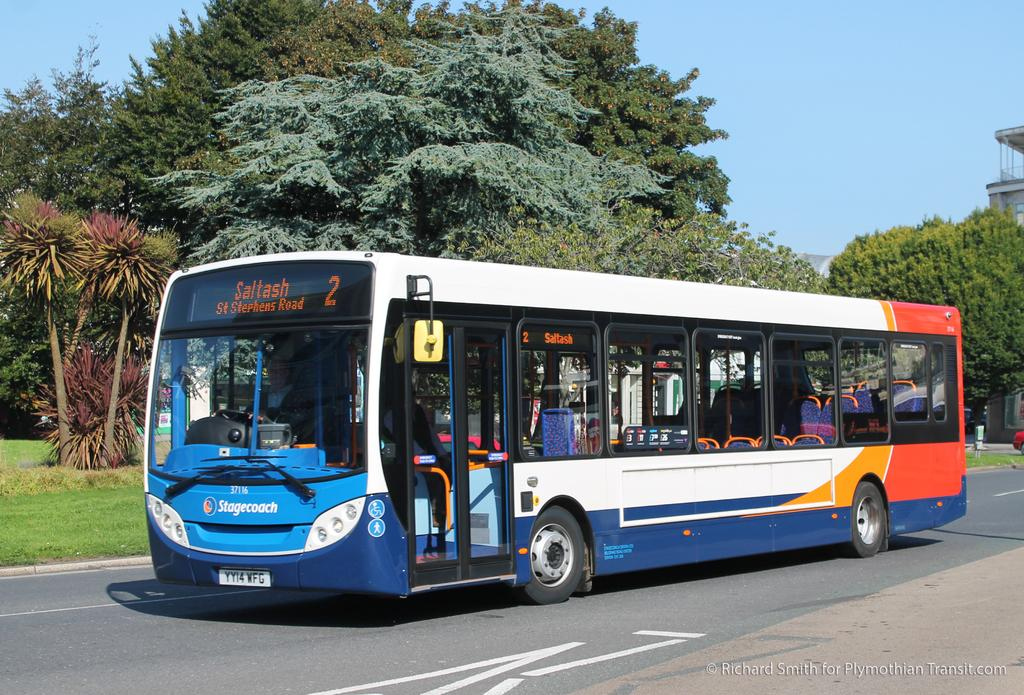<image>
Share a concise interpretation of the image provided. bus number 2 going to Saltash, St Stephens Road 